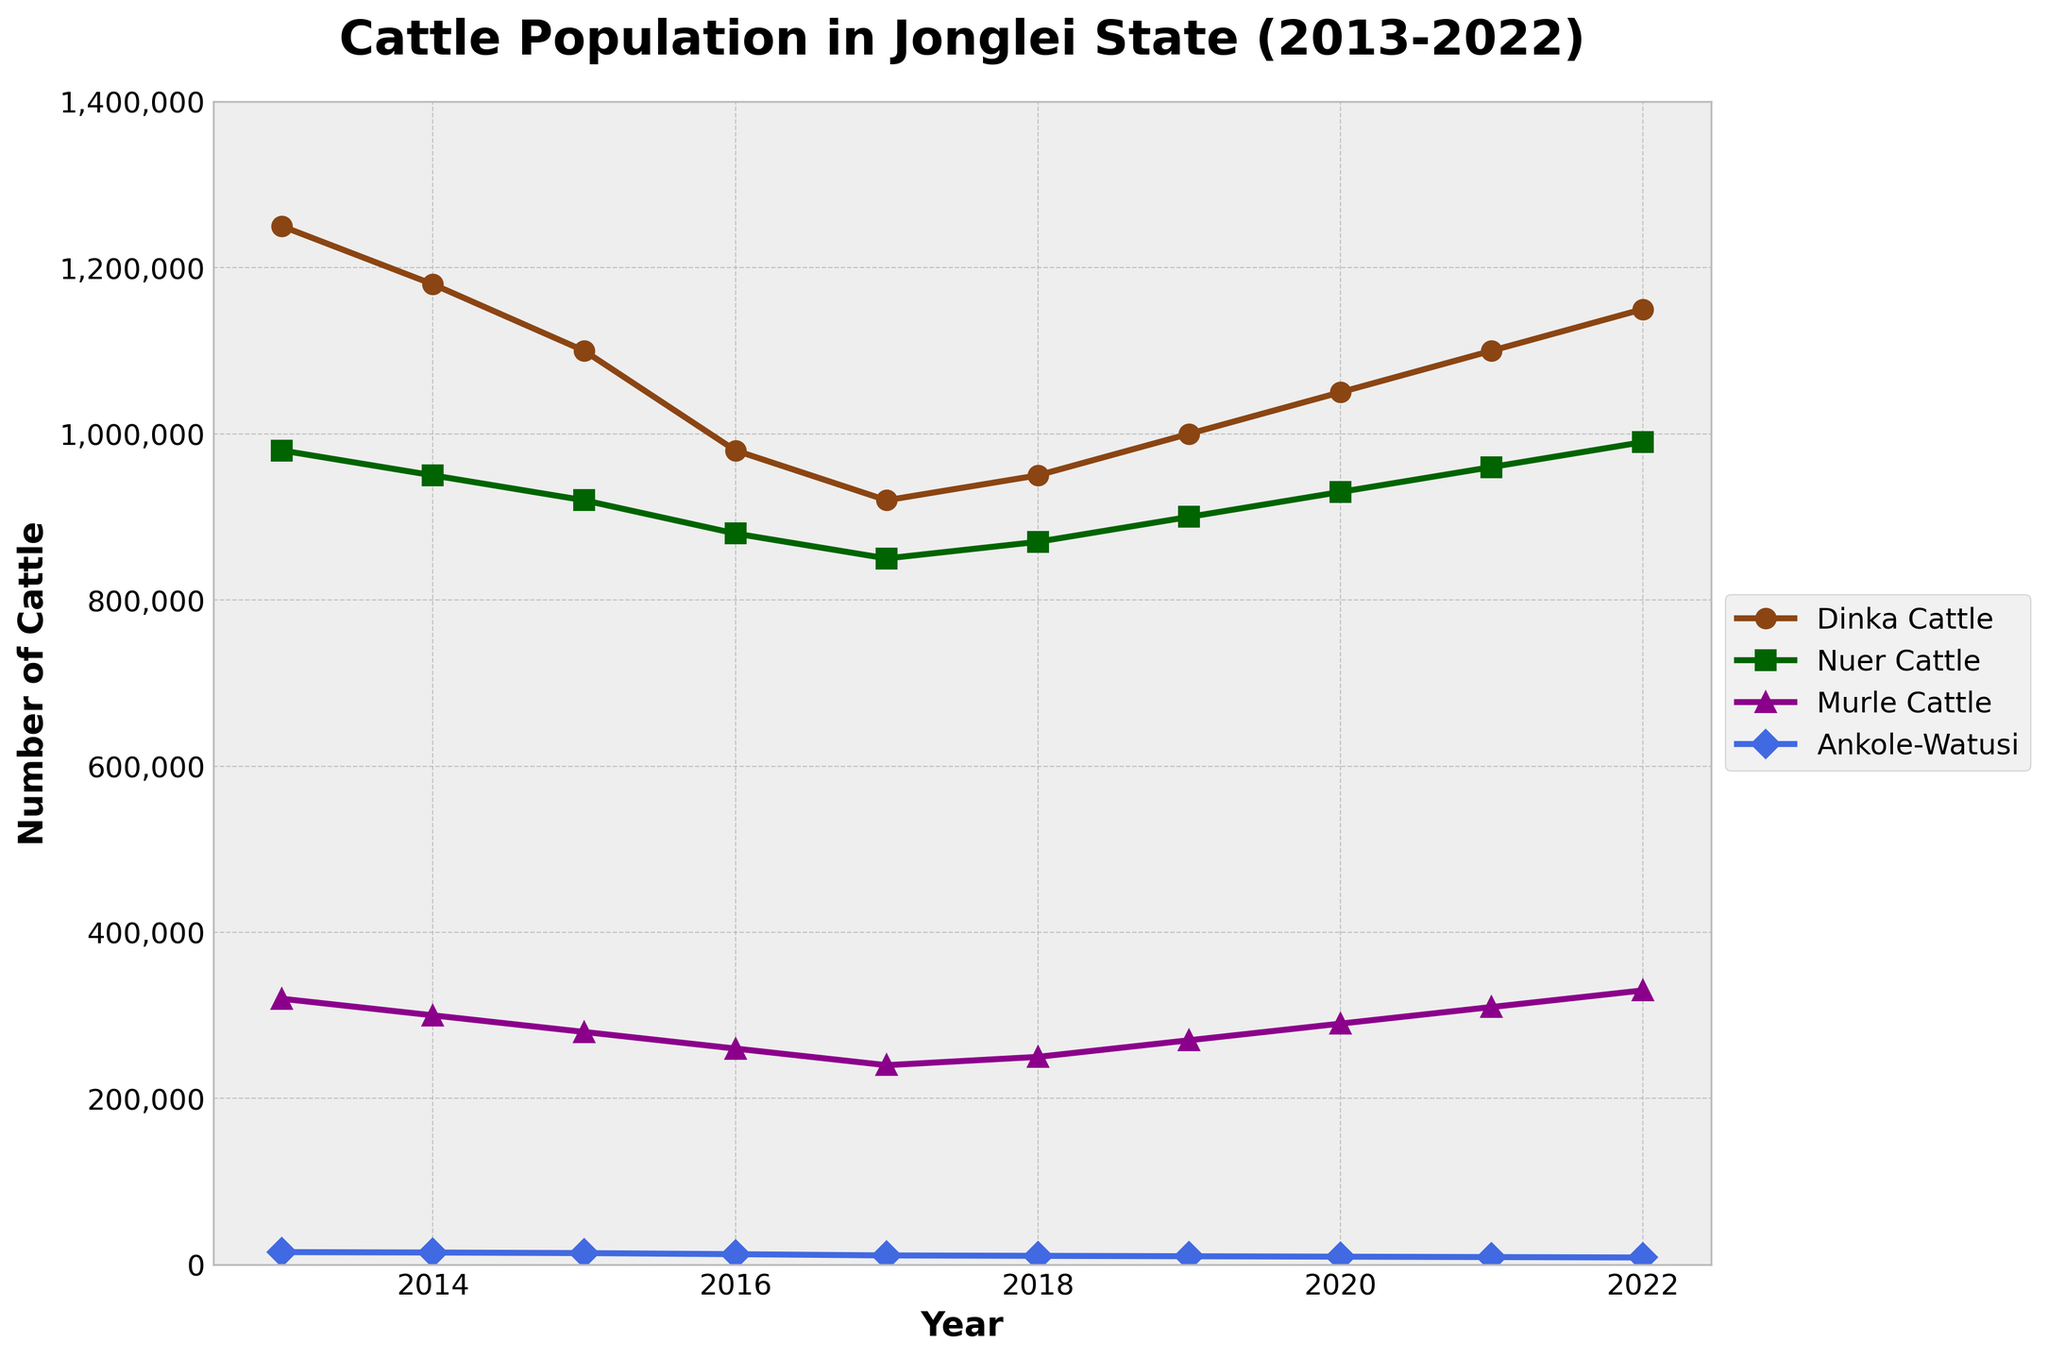what's the trend in the Dinka Cattle population from 2013 to 2022? From the figure, observe the line representing the Dinka Cattle population. It starts at 1,250,000 in 2013 and decreases to 980,000 by 2016, then starts increasing again, reaching 1,150,000 in 2022. So, the trend is a decrease from 2013 to 2016 and an increase from 2016 to 2022.
Answer: Decrease (2013-2016), increase (2016-2022) Which cattle breed had the lowest population throughout the period? Look at the lines representing each breed. The Ankole-Watusi line is consistently lower than the lines for Dinka, Nuer, and Murle Cattle throughout all years.
Answer: Ankole-Watusi What is the difference in the population of Nuer Cattle between the years with the highest and lowest values? Identify the highest and lowest values for Nuer Cattle from the figure, which are 990,000 in 2022 and 850,000 in 2017. The difference is 990,000 - 850,000 = 140,000.
Answer: 140,000 How did the population of Murle Cattle change between 2016 and 2018? Check the figure for the population of Murle Cattle in 2016 and 2018. It was 260,000 in 2016 and 250,000 in 2018. This indicates a small decrease of 10,000 over those years.
Answer: Decreased by 10,000 Which years did the population of Ankole-Watusi decrease? Look at the figure for changes in the Ankole-Watusi population. It decreased each year from 2013 to 2022.
Answer: Every year from 2013 to 2022 What is the average population of Dinka Cattle from 2013 to 2022? Sum all the population figures for Dinka Cattle from 2013 to 2022 and divide by the number of years (10). (1,250,000 + 1,180,000 + 1,100,000 + 980,000 + 920,000 + 950,000 + 1,000,000 + 1,050,000 + 1,100,000 + 1,150,000)/10. The sum is 10,680,000, and the average is 1,068,000.
Answer: 1,068,000 Between Nuer Cattle and Murle Cattle, which had a higher population in 2020, and by how much? Compare the population values for Nuer Cattle (930,000) and Murle Cattle (290,000) in 2020. Subtract the smaller value from the larger one. So, 930,000 - 290,000 = 640,000.
Answer: Nuer Cattle by 640,000 Which breed had a rising population trend from 2017 to 2022? Observe the rising trends in the figure from 2017 to 2022. The Dinka Cattle population consistently rises during this period.
Answer: Dinka Cattle Comparing 2018 to 2022, which breed had the most significant population increase? Calculate the population increase for each breed from 2018 to 2022. Dinka Cattle increased from 950,000 to 1,150,000 by 200,000. Nuer Cattle increased from 870,000 to 990,000 by 120,000. Murle Cattle increased from 250,000 to 330,000 by 80,000. Ankole-Watusi decreased. Dinka Cattle has the most significant increase.
Answer: Dinka Cattle What was the peak population of Murle Cattle, and in which year did it occur? Identify the highest Murle Cattle population from the figure, which is 330,000 in the year 2022.
Answer: 330,000 in 2022 